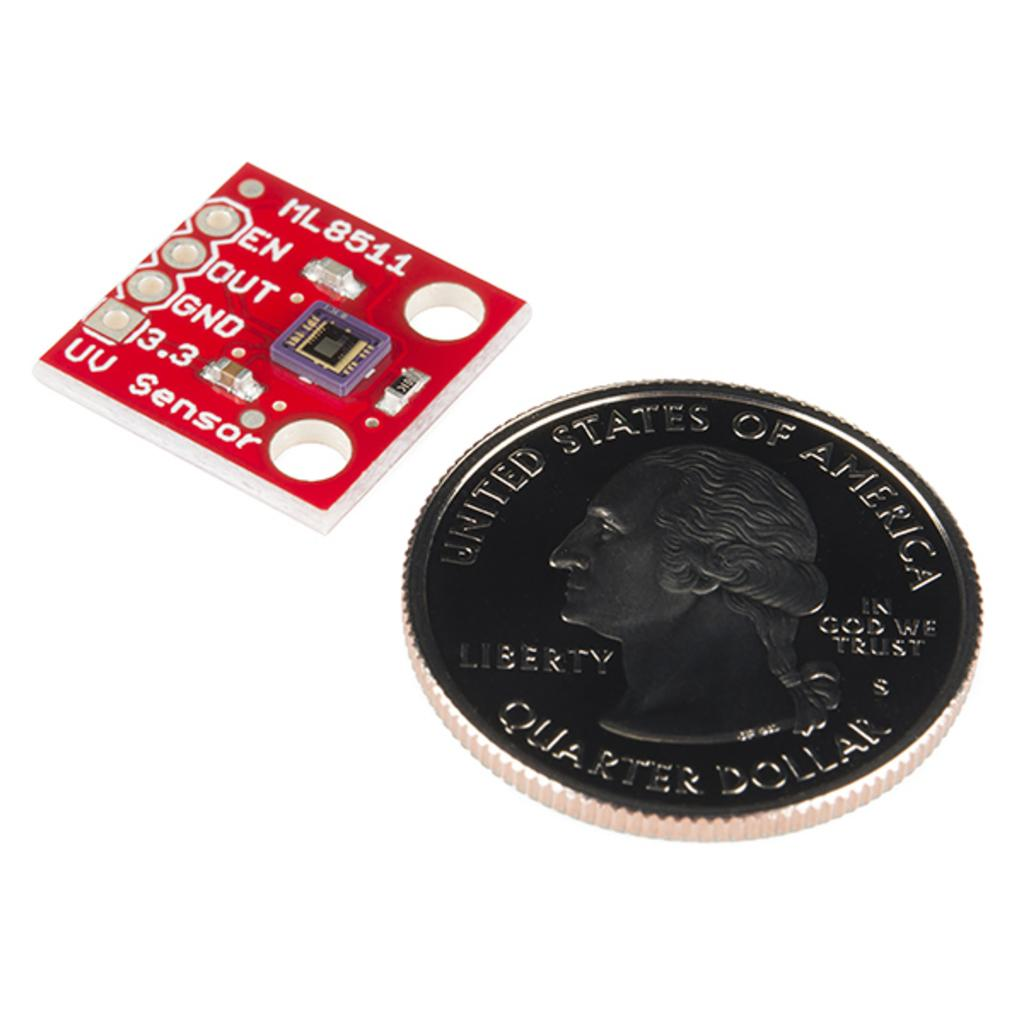<image>
Share a concise interpretation of the image provided. A coin that has the United States of America written on it 